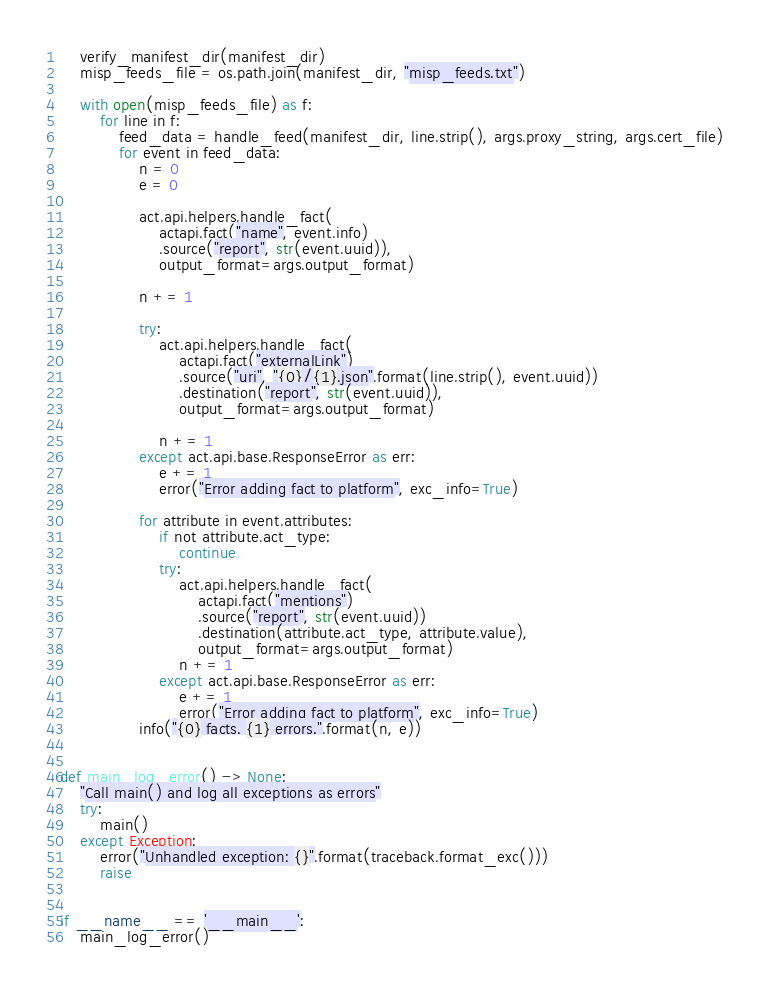Convert code to text. <code><loc_0><loc_0><loc_500><loc_500><_Python_>
    verify_manifest_dir(manifest_dir)
    misp_feeds_file = os.path.join(manifest_dir, "misp_feeds.txt")

    with open(misp_feeds_file) as f:
        for line in f:
            feed_data = handle_feed(manifest_dir, line.strip(), args.proxy_string, args.cert_file)
            for event in feed_data:
                n = 0
                e = 0

                act.api.helpers.handle_fact(
                    actapi.fact("name", event.info)
                    .source("report", str(event.uuid)),
                    output_format=args.output_format)

                n += 1

                try:
                    act.api.helpers.handle_fact(
                        actapi.fact("externalLink")
                        .source("uri", "{0}/{1}.json".format(line.strip(), event.uuid))
                        .destination("report", str(event.uuid)),
                        output_format=args.output_format)

                    n += 1
                except act.api.base.ResponseError as err:
                    e += 1
                    error("Error adding fact to platform", exc_info=True)

                for attribute in event.attributes:
                    if not attribute.act_type:
                        continue
                    try:
                        act.api.helpers.handle_fact(
                            actapi.fact("mentions")
                            .source("report", str(event.uuid))
                            .destination(attribute.act_type, attribute.value),
                            output_format=args.output_format)
                        n += 1
                    except act.api.base.ResponseError as err:
                        e += 1
                        error("Error adding fact to platform", exc_info=True)
                info("{0} facts. {1} errors.".format(n, e))


def main_log_error() -> None:
    "Call main() and log all exceptions as errors"
    try:
        main()
    except Exception:
        error("Unhandled exception: {}".format(traceback.format_exc()))
        raise


if __name__ == '__main__':
    main_log_error()
</code> 